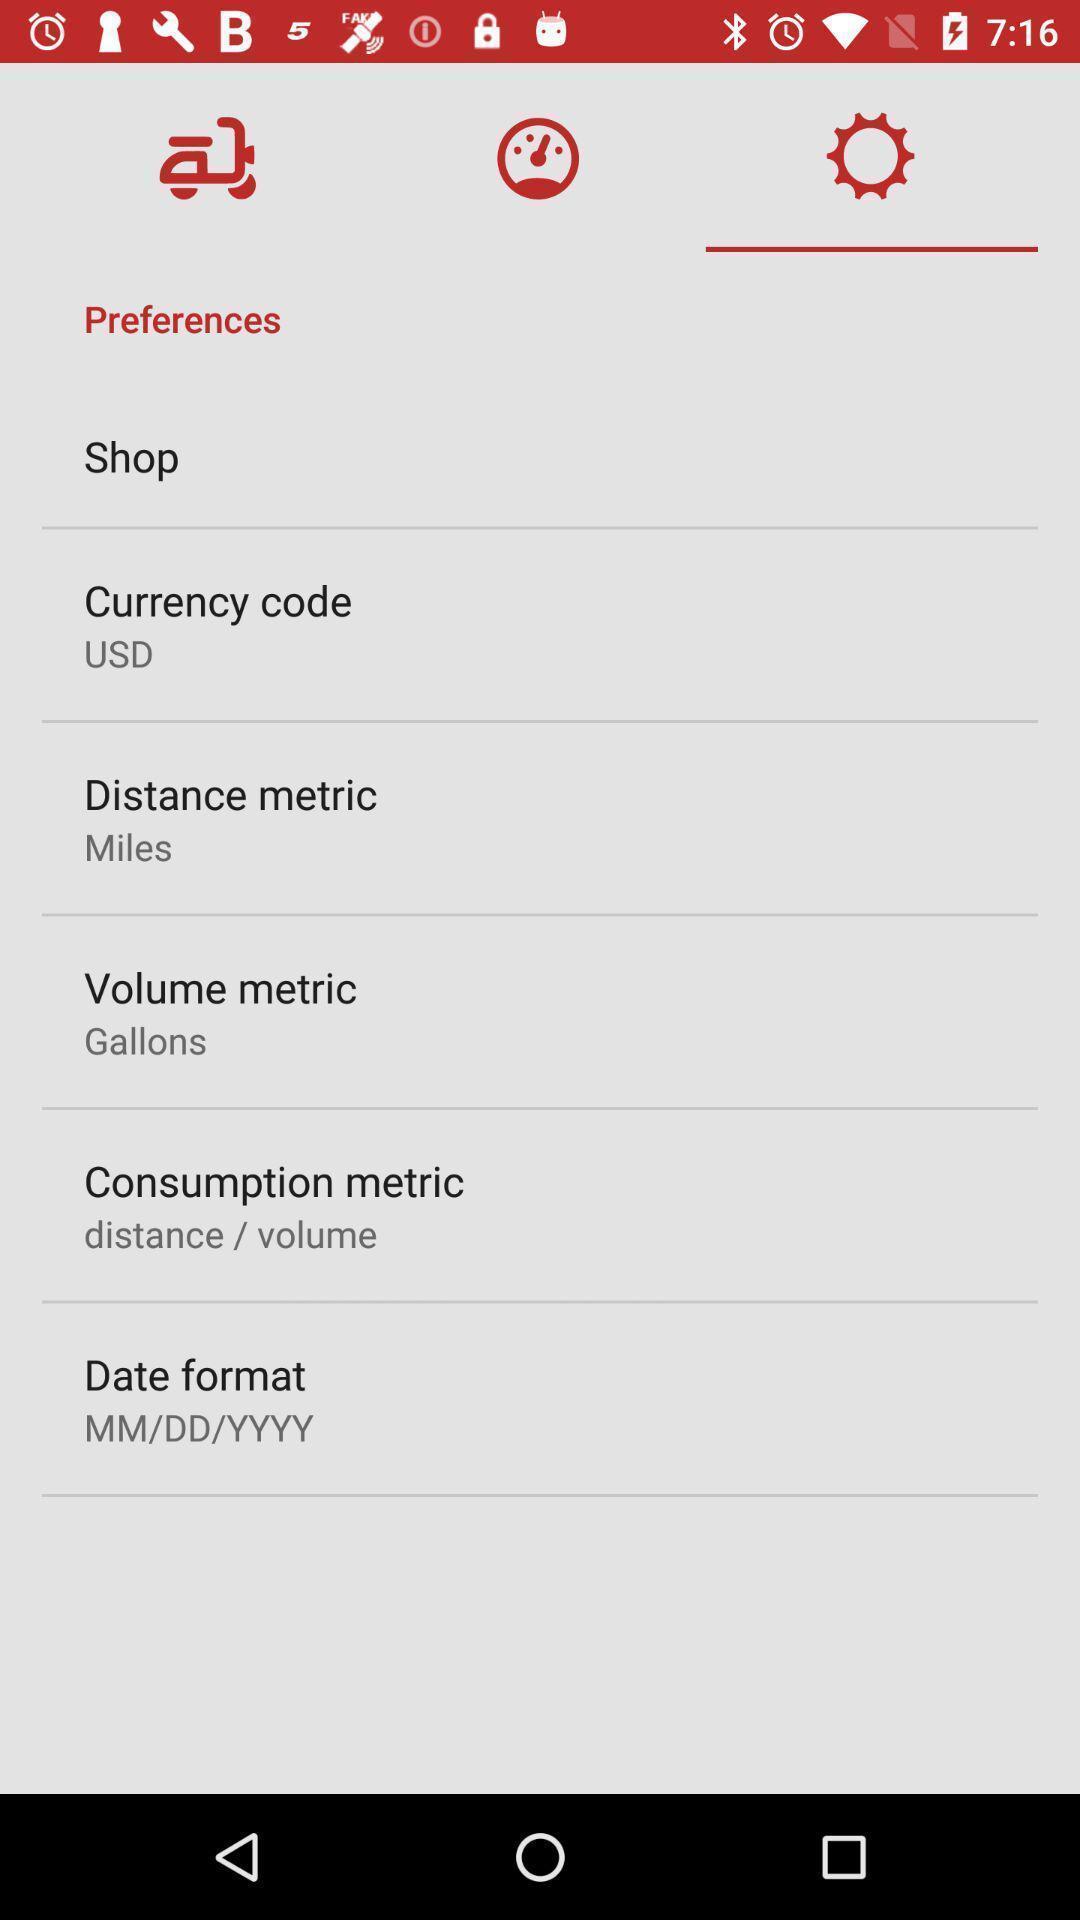Explain the elements present in this screenshot. Settings page displayed. 